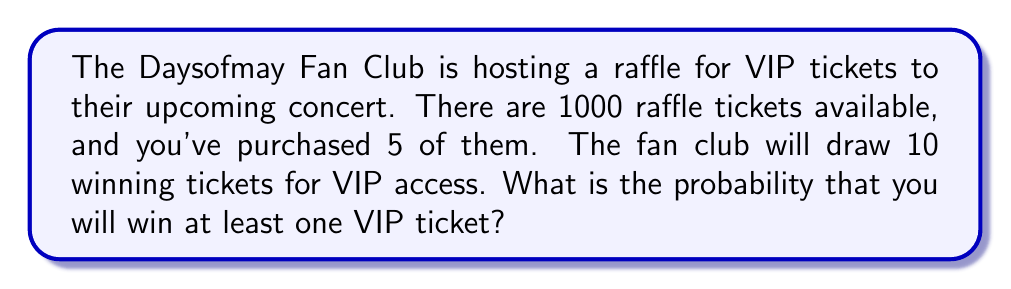Help me with this question. Let's approach this step-by-step using the concept of complementary probability:

1) First, let's calculate the probability of not winning any VIP ticket.

2) The total number of ways to choose 10 winning tickets from 995 non-your tickets:
   $$\binom{995}{10}$$

3) The total number of ways to choose 10 winning tickets from all 1000 tickets:
   $$\binom{1000}{10}$$

4) The probability of not winning any VIP ticket is:
   $$P(\text{no win}) = \frac{\binom{995}{10}}{\binom{1000}{10}}$$

5) Now, the probability of winning at least one VIP ticket is the complement of this:
   $$P(\text{at least one win}) = 1 - P(\text{no win}) = 1 - \frac{\binom{995}{10}}{\binom{1000}{10}}$$

6) Let's calculate this:
   $$1 - \frac{995!/(985! \cdot 10!)}{1000!/(990! \cdot 10!)} = 1 - \frac{995 \cdot 994 \cdot 993 \cdot 992 \cdot 991}{1000 \cdot 999 \cdot 998 \cdot 997 \cdot 996}$$

7) Simplifying:
   $$1 - 0.9506 = 0.0494$$

Therefore, the probability of winning at least one VIP ticket is approximately 0.0494 or 4.94%.
Answer: $0.0494$ or $4.94\%$ 